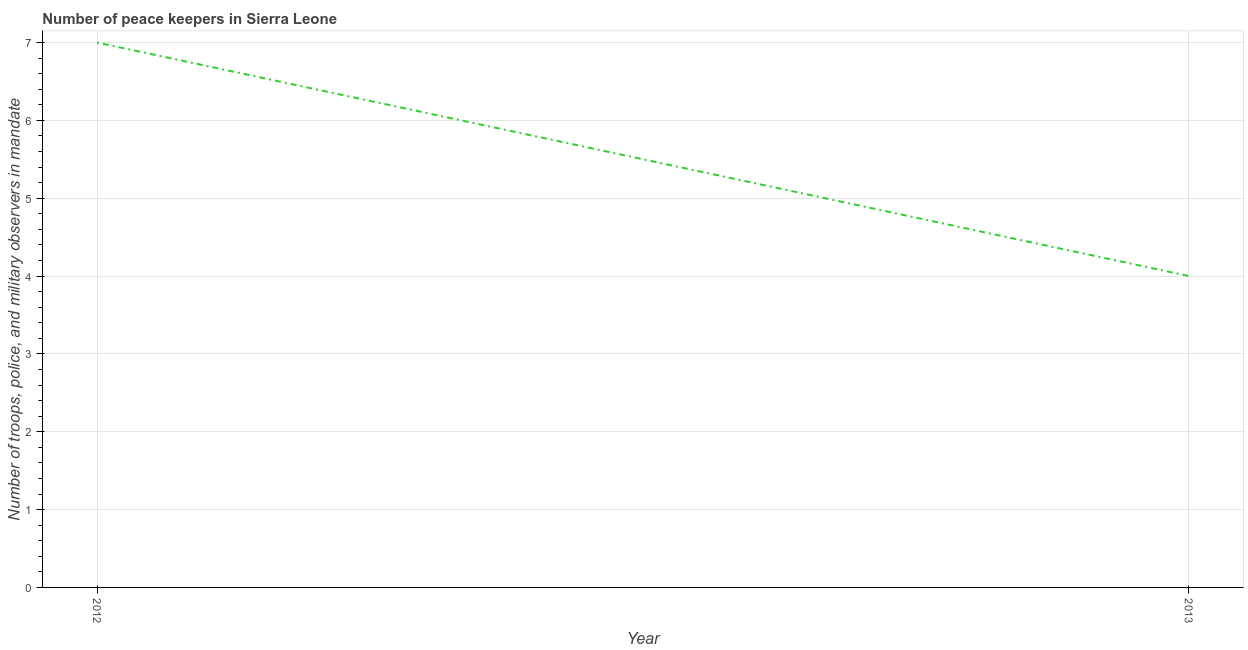What is the number of peace keepers in 2012?
Make the answer very short. 7. Across all years, what is the maximum number of peace keepers?
Your answer should be very brief. 7. Across all years, what is the minimum number of peace keepers?
Your answer should be very brief. 4. In which year was the number of peace keepers minimum?
Your answer should be compact. 2013. What is the sum of the number of peace keepers?
Provide a short and direct response. 11. What is the difference between the number of peace keepers in 2012 and 2013?
Offer a terse response. 3. Do a majority of the years between 2013 and 2012 (inclusive) have number of peace keepers greater than 0.6000000000000001 ?
Your answer should be compact. No. What is the ratio of the number of peace keepers in 2012 to that in 2013?
Your answer should be very brief. 1.75. Does the number of peace keepers monotonically increase over the years?
Your answer should be compact. No. How many lines are there?
Offer a very short reply. 1. How many years are there in the graph?
Your answer should be compact. 2. Are the values on the major ticks of Y-axis written in scientific E-notation?
Offer a very short reply. No. Does the graph contain grids?
Provide a succinct answer. Yes. What is the title of the graph?
Give a very brief answer. Number of peace keepers in Sierra Leone. What is the label or title of the X-axis?
Ensure brevity in your answer.  Year. What is the label or title of the Y-axis?
Keep it short and to the point. Number of troops, police, and military observers in mandate. What is the Number of troops, police, and military observers in mandate of 2012?
Ensure brevity in your answer.  7. What is the difference between the Number of troops, police, and military observers in mandate in 2012 and 2013?
Your answer should be compact. 3. 